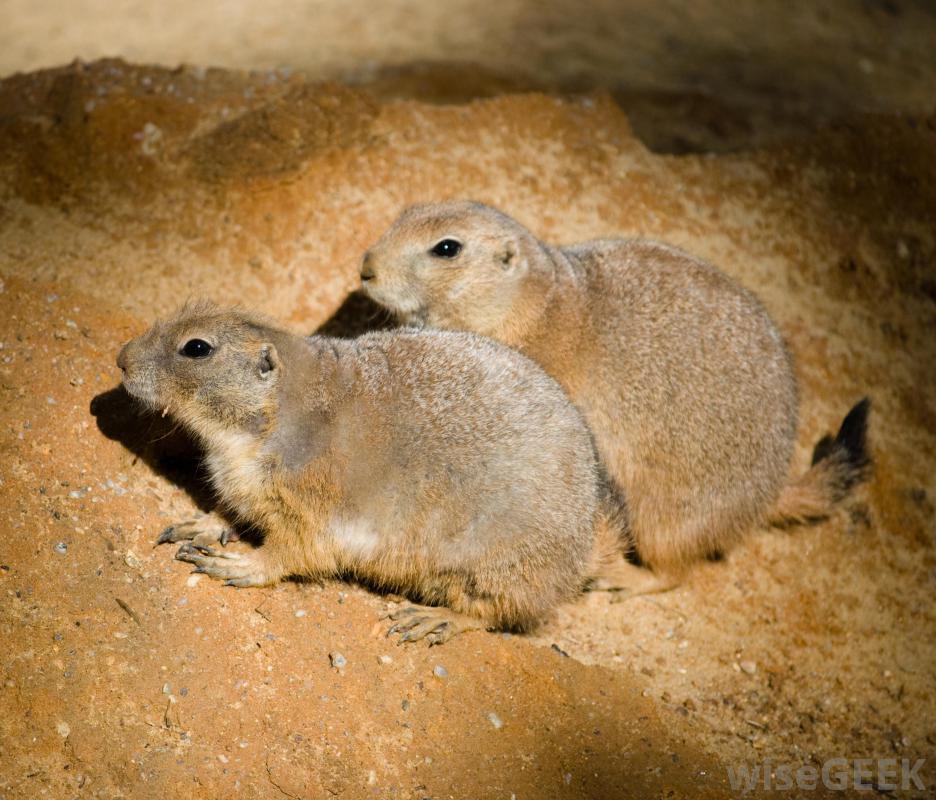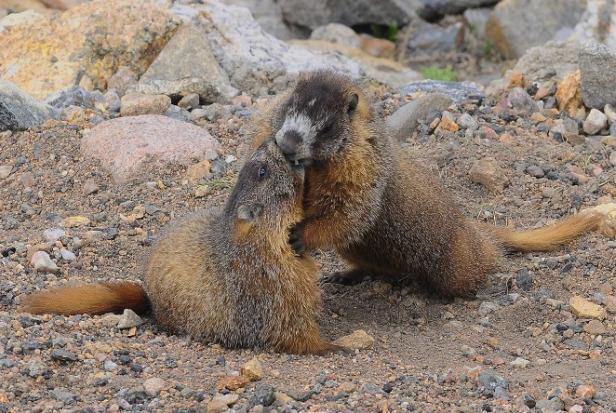The first image is the image on the left, the second image is the image on the right. Given the left and right images, does the statement "The left image contains two rodents that are face to face." hold true? Answer yes or no. No. 